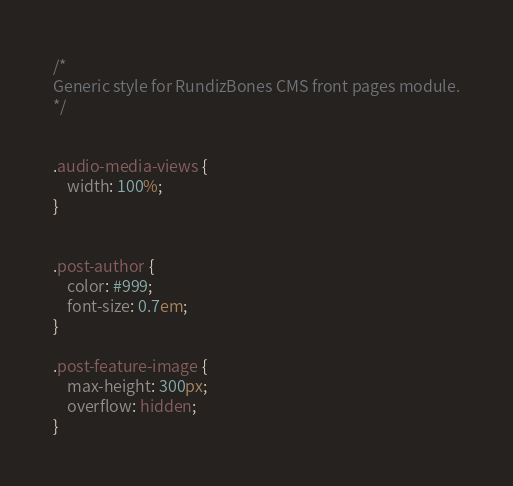Convert code to text. <code><loc_0><loc_0><loc_500><loc_500><_CSS_>/*
Generic style for RundizBones CMS front pages module.
*/


.audio-media-views {
    width: 100%;
}


.post-author {
    color: #999;
    font-size: 0.7em;
}

.post-feature-image {
    max-height: 300px;
    overflow: hidden;
}</code> 